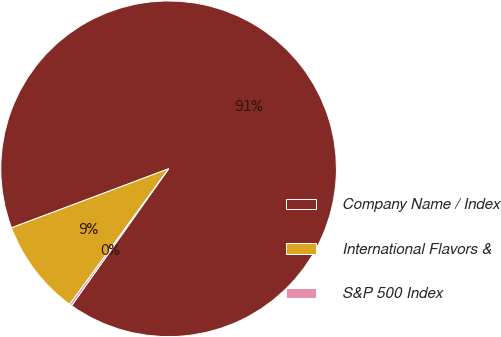Convert chart. <chart><loc_0><loc_0><loc_500><loc_500><pie_chart><fcel>Company Name / Index<fcel>International Flavors &<fcel>S&P 500 Index<nl><fcel>90.53%<fcel>9.25%<fcel>0.22%<nl></chart> 